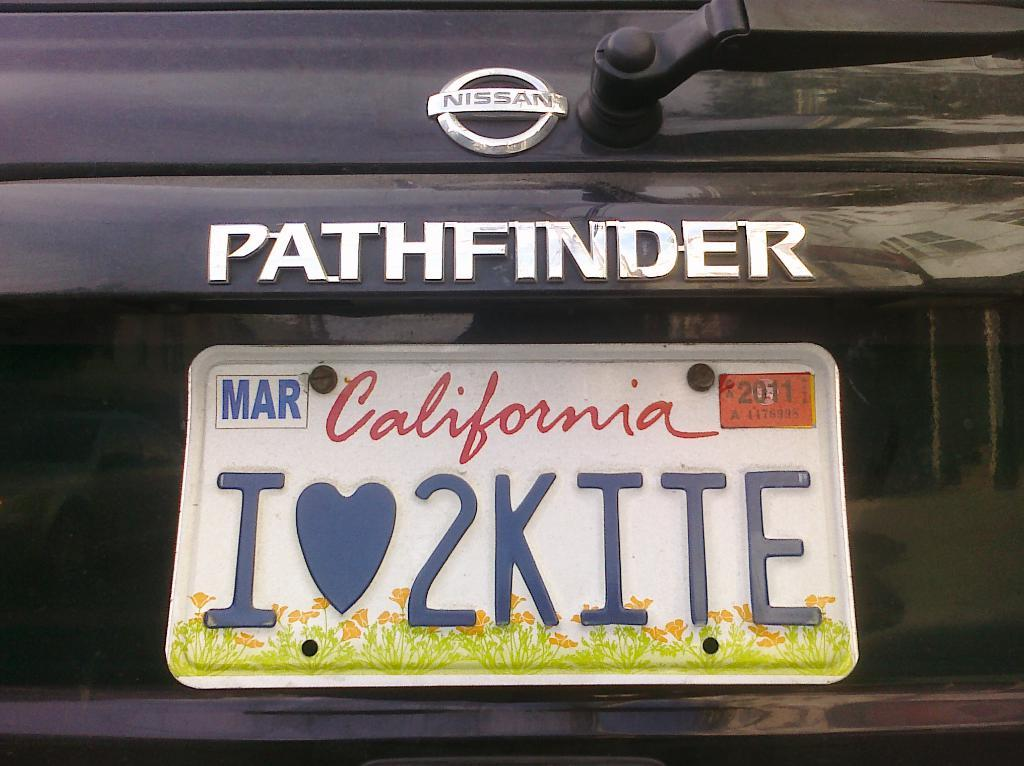Provide a one-sentence caption for the provided image. The back bumper of a Nissan Pathfinder with a California state license plate on it. 